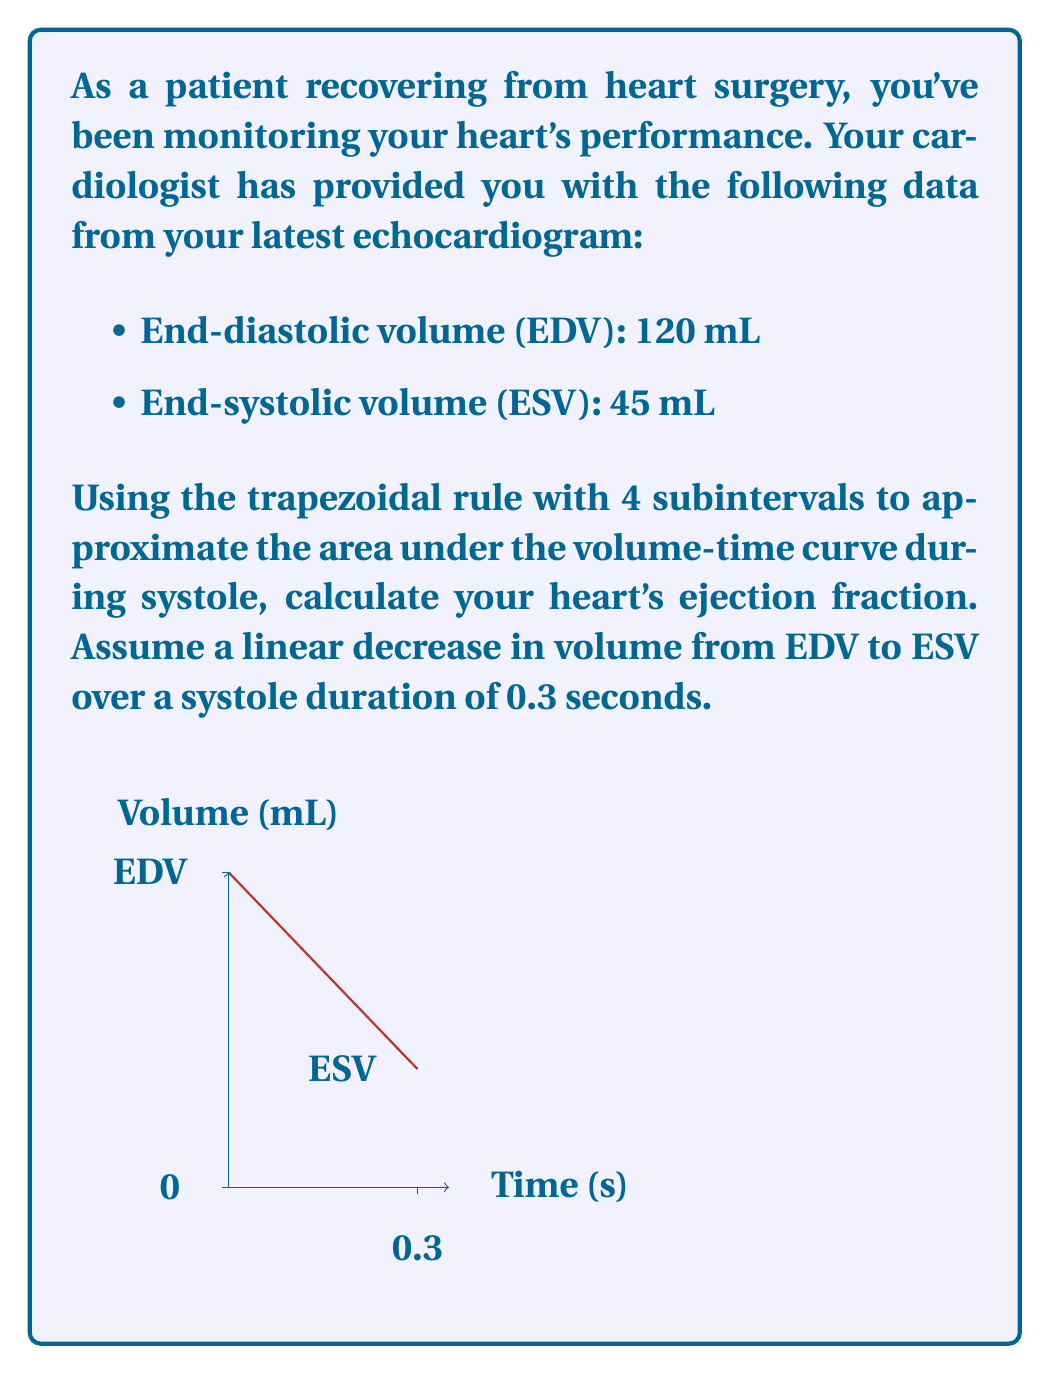Provide a solution to this math problem. Let's approach this step-by-step:

1) The ejection fraction (EF) is calculated using the formula:

   $$ EF = \frac{EDV - ESV}{EDV} \times 100\% $$

2) We need to use the trapezoidal rule to approximate the area under the volume-time curve during systole. The trapezoidal rule with n subintervals is given by:

   $$ \int_a^b f(x)dx \approx \frac{b-a}{2n}[f(a) + 2f(x_1) + 2f(x_2) + ... + 2f(x_{n-1}) + f(b)] $$

3) In our case:
   - a = 0, b = 0.3
   - n = 4
   - f(0) = 120, f(0.3) = 45

4) We need to find f(x1), f(x2), and f(x3):
   - x1 = 0.075, f(x1) = 120 - (120-45)*(0.075/0.3) = 101.25
   - x2 = 0.15,  f(x2) = 120 - (120-45)*(0.15/0.3) = 82.5
   - x3 = 0.225, f(x3) = 120 - (120-45)*(0.225/0.3) = 63.75

5) Applying the trapezoidal rule:

   $$ Area \approx \frac{0.3}{2(4)}[120 + 2(101.25) + 2(82.5) + 2(63.75) + 45] $$
   $$ = 0.0375[120 + 202.5 + 165 + 127.5 + 45] $$
   $$ = 0.0375(660) = 24.75 $$

6) The average volume during systole is:
   $$ V_{avg} = \frac{Area}{Time} = \frac{24.75}{0.3} = 82.5 \text{ mL} $$

7) Now we can calculate the ejection fraction:
   $$ EF = \frac{120 - 82.5}{120} \times 100\% = 31.25\% $$
Answer: 31.25% 